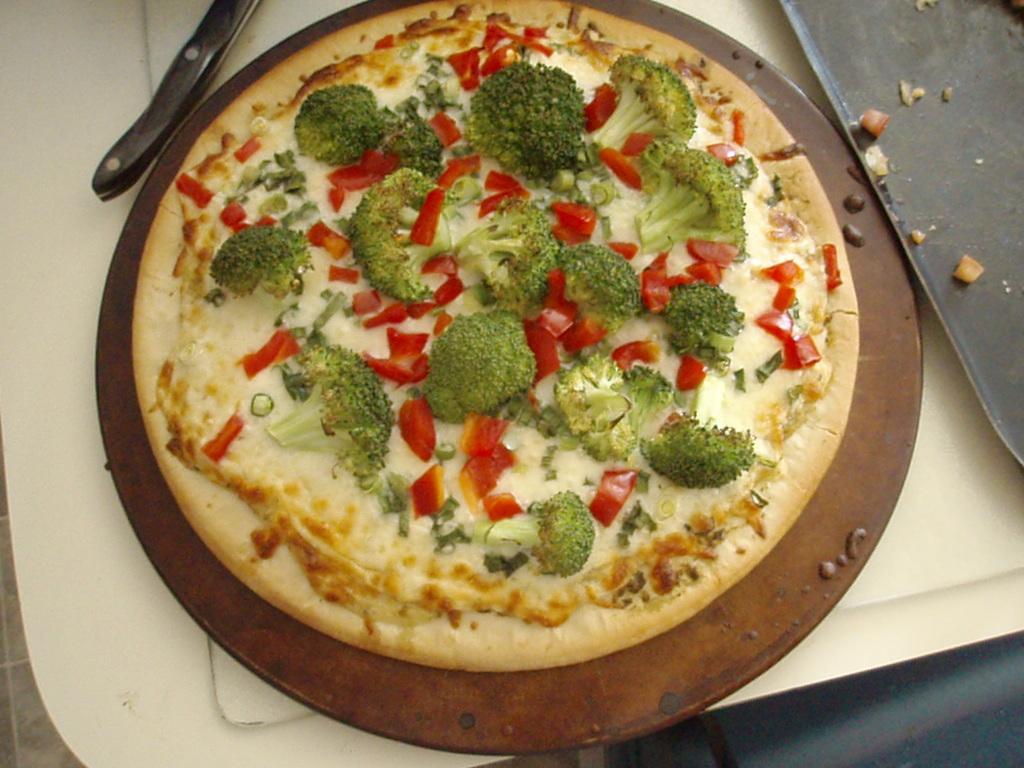In one or two sentences, can you explain what this image depicts? In the image there is a white tray. On the tray there is a round shape wooden object with pizza on it. And also there is a knife on the tray. On the right side of the image there is a black tray. 